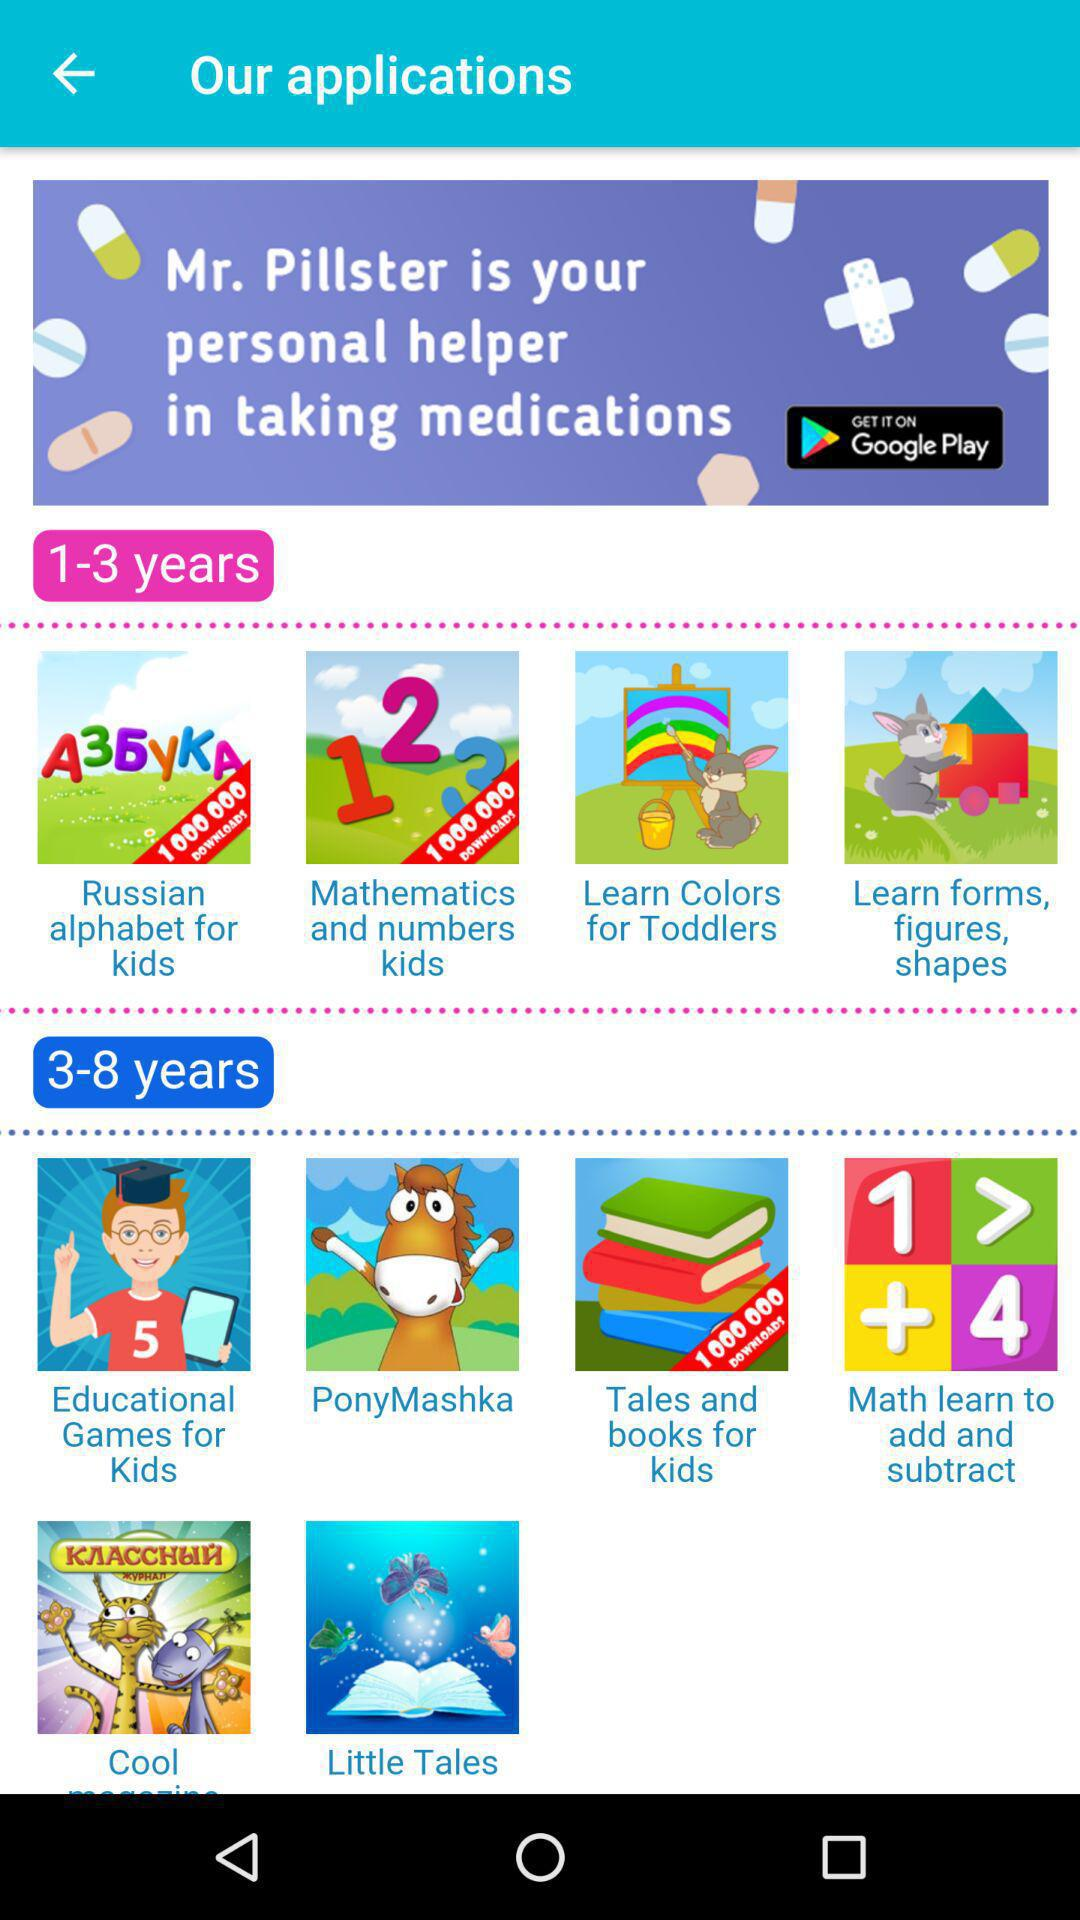Which applications are for 3-8 years old? The applications that are for 3-8 years old are "Educational Games for Kids", "PonyMashka", "Tales and books for kids", "Math learn to add and subtract" and "Little Tales". 